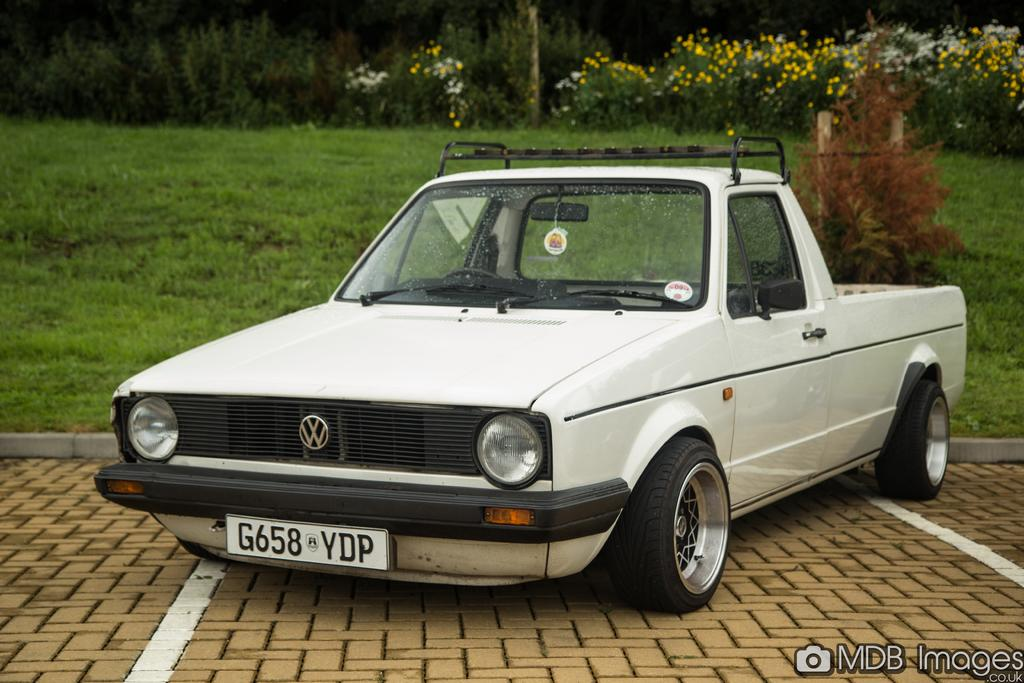What is the main subject of the image? There is a car on the road in the image. What else can be seen in the image besides the car? There is a text in the image, and there are grass, plants, and trees in the background. What time of day was the image taken? The image was taken during the day. How many bears can be seen in the image? There are no bears present in the image. What color is the silver owl in the image? There is no silver owl present in the image. 